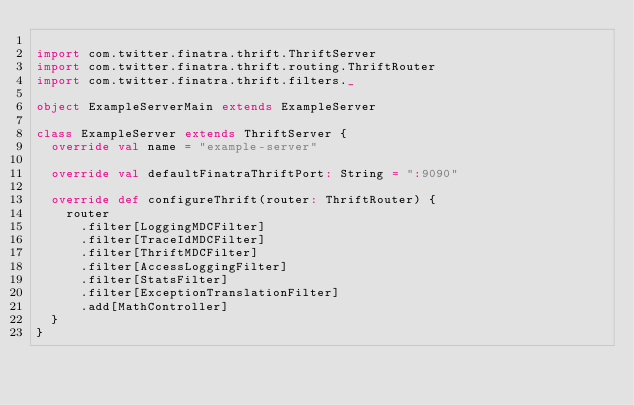<code> <loc_0><loc_0><loc_500><loc_500><_Scala_>
import com.twitter.finatra.thrift.ThriftServer
import com.twitter.finatra.thrift.routing.ThriftRouter
import com.twitter.finatra.thrift.filters._

object ExampleServerMain extends ExampleServer

class ExampleServer extends ThriftServer {
  override val name = "example-server"

  override val defaultFinatraThriftPort: String = ":9090"

  override def configureThrift(router: ThriftRouter) {
    router
      .filter[LoggingMDCFilter]
      .filter[TraceIdMDCFilter]
      .filter[ThriftMDCFilter]
      .filter[AccessLoggingFilter]
      .filter[StatsFilter]
      .filter[ExceptionTranslationFilter]
      .add[MathController]
  }
}
</code> 